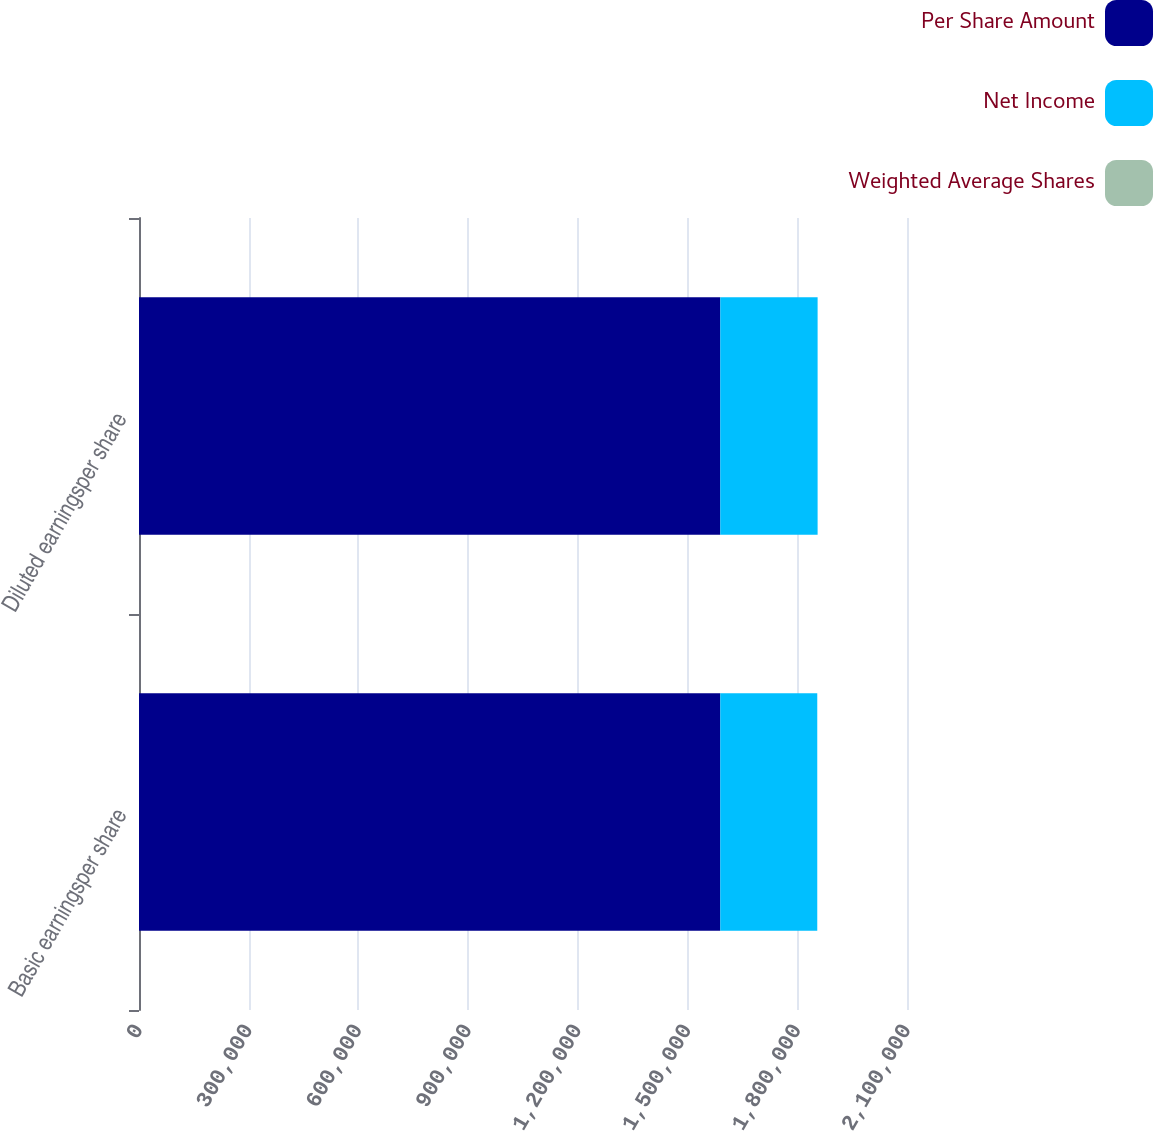Convert chart to OTSL. <chart><loc_0><loc_0><loc_500><loc_500><stacked_bar_chart><ecel><fcel>Basic earningsper share<fcel>Diluted earningsper share<nl><fcel>Per Share Amount<fcel>1.58947e+06<fcel>1.58947e+06<nl><fcel>Net Income<fcel>265155<fcel>266105<nl><fcel>Weighted Average Shares<fcel>5.99<fcel>5.97<nl></chart> 